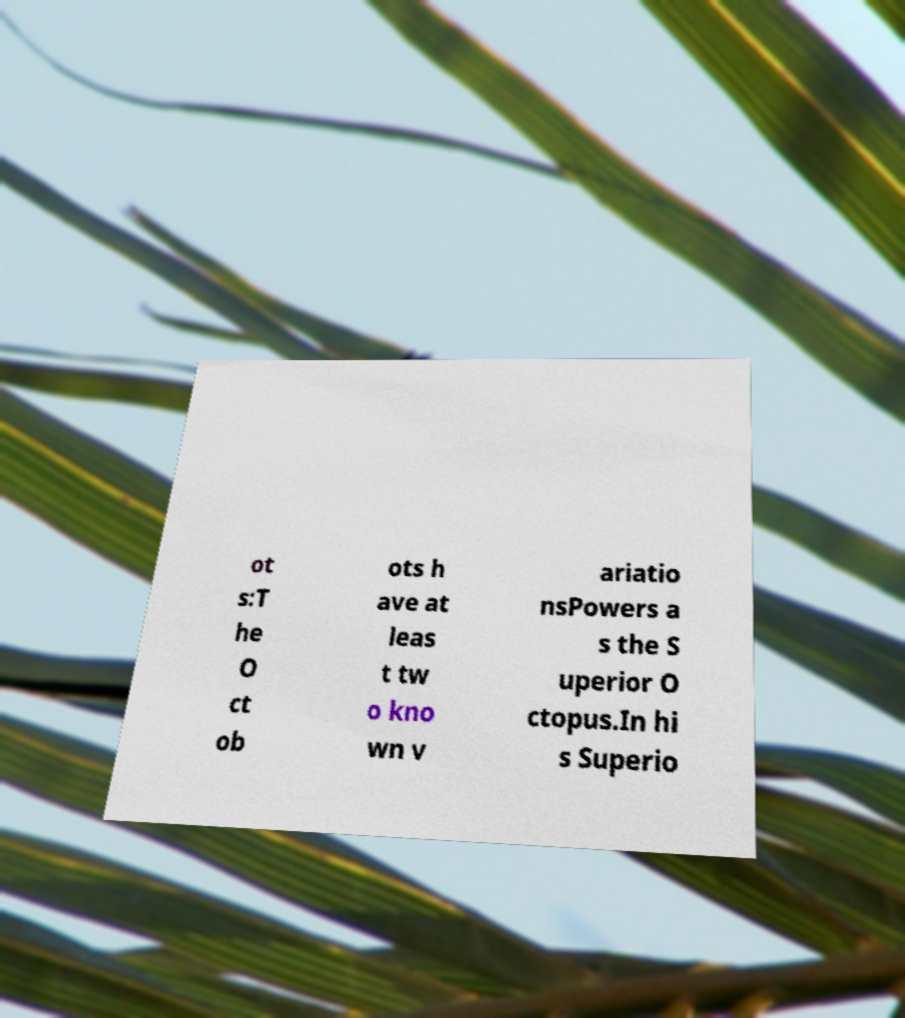Can you read and provide the text displayed in the image?This photo seems to have some interesting text. Can you extract and type it out for me? ot s:T he O ct ob ots h ave at leas t tw o kno wn v ariatio nsPowers a s the S uperior O ctopus.In hi s Superio 